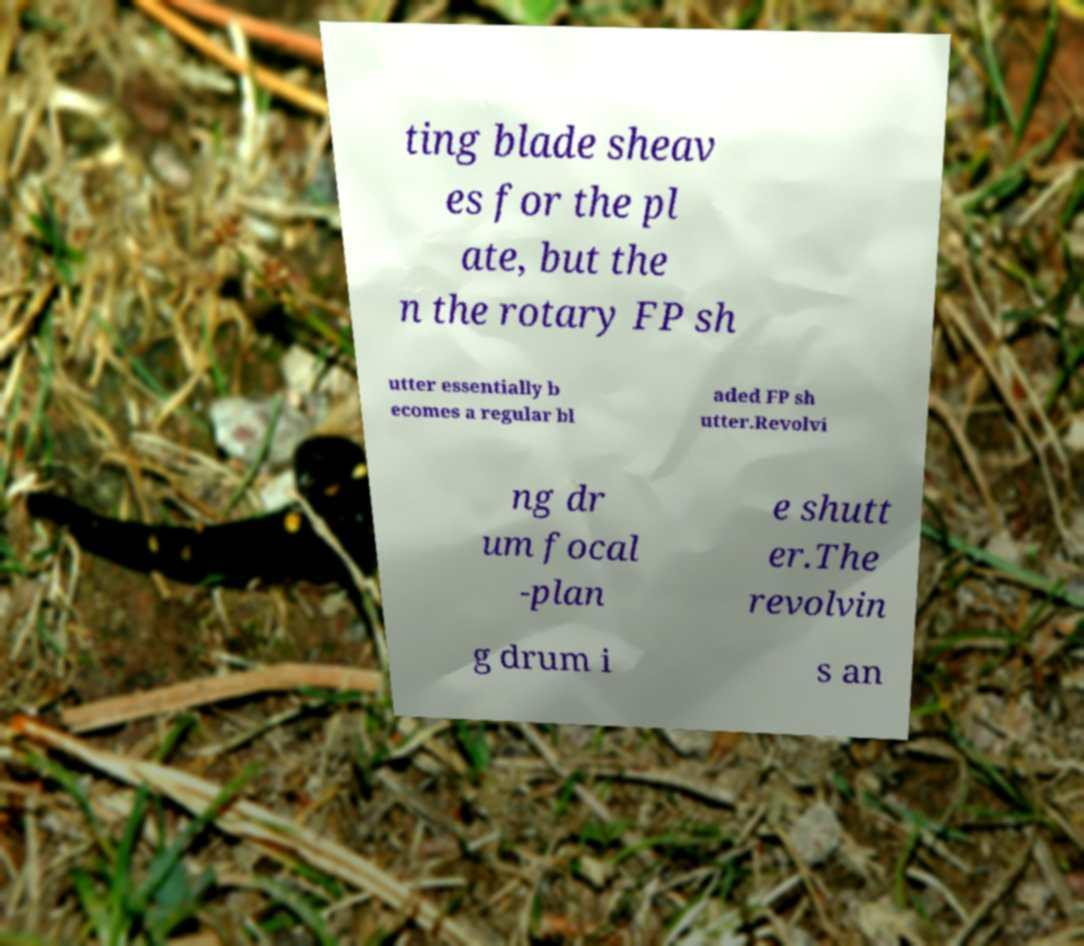I need the written content from this picture converted into text. Can you do that? ting blade sheav es for the pl ate, but the n the rotary FP sh utter essentially b ecomes a regular bl aded FP sh utter.Revolvi ng dr um focal -plan e shutt er.The revolvin g drum i s an 